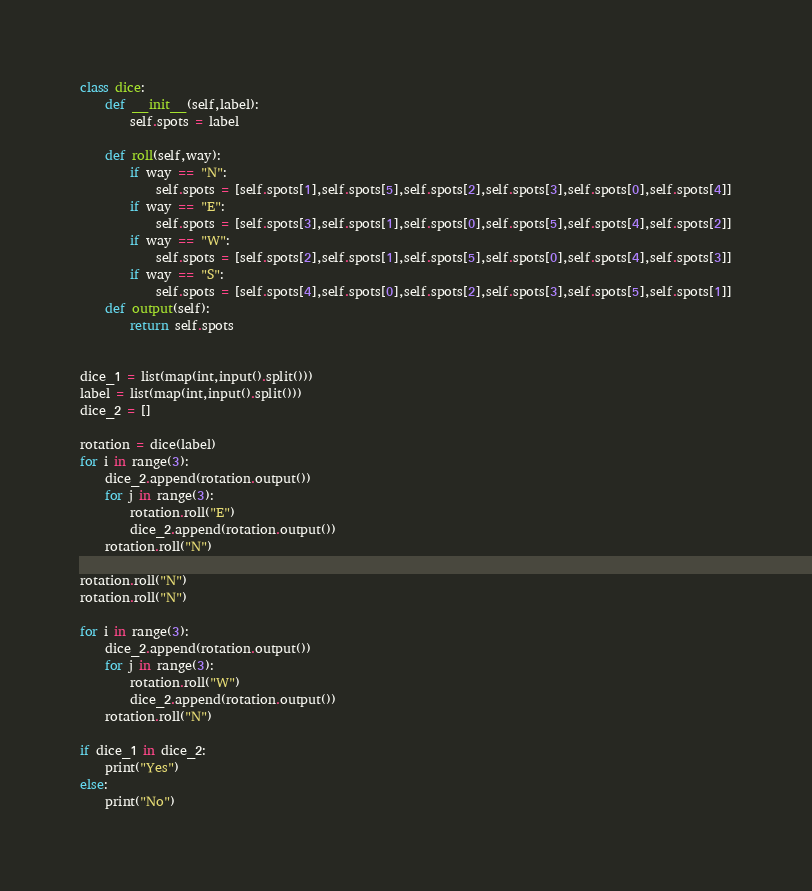<code> <loc_0><loc_0><loc_500><loc_500><_Python_>class dice:
    def __init__(self,label):
        self.spots = label

    def roll(self,way):
        if way == "N":
            self.spots = [self.spots[1],self.spots[5],self.spots[2],self.spots[3],self.spots[0],self.spots[4]]
        if way == "E":
            self.spots = [self.spots[3],self.spots[1],self.spots[0],self.spots[5],self.spots[4],self.spots[2]]
        if way == "W":
            self.spots = [self.spots[2],self.spots[1],self.spots[5],self.spots[0],self.spots[4],self.spots[3]]
        if way == "S":
            self.spots = [self.spots[4],self.spots[0],self.spots[2],self.spots[3],self.spots[5],self.spots[1]]
    def output(self):
        return self.spots


dice_1 = list(map(int,input().split()))
label = list(map(int,input().split()))
dice_2 = []

rotation = dice(label)
for i in range(3):
    dice_2.append(rotation.output())
    for j in range(3):
        rotation.roll("E")
        dice_2.append(rotation.output())
    rotation.roll("N")

rotation.roll("N")
rotation.roll("N")

for i in range(3):
    dice_2.append(rotation.output())
    for j in range(3):
        rotation.roll("W")
        dice_2.append(rotation.output())
    rotation.roll("N")

if dice_1 in dice_2:
    print("Yes")
else:
    print("No")</code> 